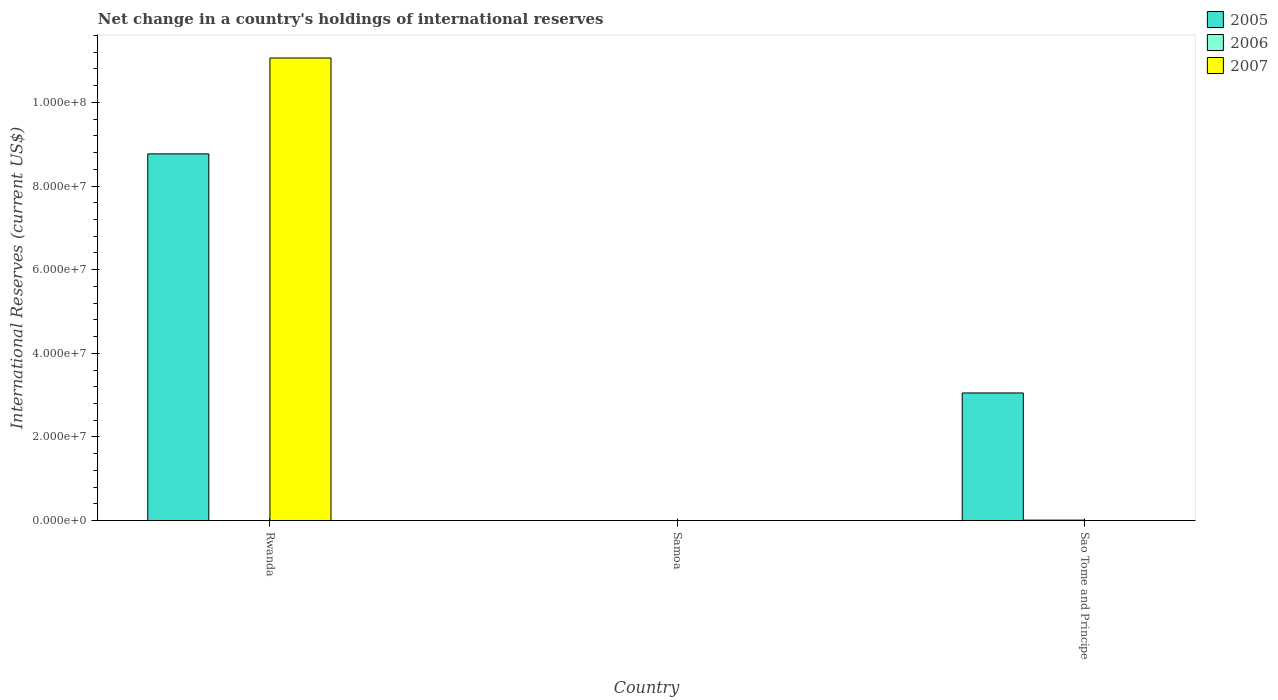How many bars are there on the 3rd tick from the right?
Ensure brevity in your answer.  2. What is the label of the 1st group of bars from the left?
Offer a terse response. Rwanda. What is the international reserves in 2005 in Samoa?
Offer a very short reply. 0. Across all countries, what is the maximum international reserves in 2006?
Make the answer very short. 1.11e+05. In which country was the international reserves in 2006 maximum?
Your response must be concise. Sao Tome and Principe. What is the total international reserves in 2006 in the graph?
Make the answer very short. 1.11e+05. What is the difference between the international reserves in 2005 in Rwanda and that in Sao Tome and Principe?
Your answer should be compact. 5.72e+07. What is the difference between the international reserves in 2005 in Sao Tome and Principe and the international reserves in 2007 in Rwanda?
Your answer should be compact. -8.01e+07. What is the average international reserves in 2005 per country?
Ensure brevity in your answer.  3.94e+07. What is the difference between the international reserves of/in 2005 and international reserves of/in 2006 in Sao Tome and Principe?
Give a very brief answer. 3.04e+07. In how many countries, is the international reserves in 2007 greater than 56000000 US$?
Your response must be concise. 1. What is the ratio of the international reserves in 2005 in Rwanda to that in Sao Tome and Principe?
Offer a very short reply. 2.87. Is the international reserves in 2005 in Rwanda less than that in Sao Tome and Principe?
Give a very brief answer. No. What is the difference between the highest and the lowest international reserves in 2005?
Offer a terse response. 8.77e+07. Is it the case that in every country, the sum of the international reserves in 2007 and international reserves in 2005 is greater than the international reserves in 2006?
Your answer should be very brief. No. How many bars are there?
Give a very brief answer. 4. Are all the bars in the graph horizontal?
Provide a succinct answer. No. How many countries are there in the graph?
Your response must be concise. 3. Does the graph contain grids?
Offer a terse response. No. Where does the legend appear in the graph?
Ensure brevity in your answer.  Top right. How many legend labels are there?
Ensure brevity in your answer.  3. How are the legend labels stacked?
Make the answer very short. Vertical. What is the title of the graph?
Your answer should be very brief. Net change in a country's holdings of international reserves. What is the label or title of the Y-axis?
Offer a terse response. International Reserves (current US$). What is the International Reserves (current US$) of 2005 in Rwanda?
Your answer should be very brief. 8.77e+07. What is the International Reserves (current US$) of 2006 in Rwanda?
Offer a terse response. 0. What is the International Reserves (current US$) in 2007 in Rwanda?
Give a very brief answer. 1.11e+08. What is the International Reserves (current US$) of 2005 in Samoa?
Make the answer very short. 0. What is the International Reserves (current US$) of 2006 in Samoa?
Give a very brief answer. 0. What is the International Reserves (current US$) in 2007 in Samoa?
Keep it short and to the point. 0. What is the International Reserves (current US$) in 2005 in Sao Tome and Principe?
Give a very brief answer. 3.05e+07. What is the International Reserves (current US$) in 2006 in Sao Tome and Principe?
Keep it short and to the point. 1.11e+05. What is the International Reserves (current US$) in 2007 in Sao Tome and Principe?
Provide a succinct answer. 0. Across all countries, what is the maximum International Reserves (current US$) of 2005?
Provide a short and direct response. 8.77e+07. Across all countries, what is the maximum International Reserves (current US$) in 2006?
Make the answer very short. 1.11e+05. Across all countries, what is the maximum International Reserves (current US$) of 2007?
Your answer should be compact. 1.11e+08. What is the total International Reserves (current US$) in 2005 in the graph?
Provide a short and direct response. 1.18e+08. What is the total International Reserves (current US$) of 2006 in the graph?
Offer a very short reply. 1.11e+05. What is the total International Reserves (current US$) in 2007 in the graph?
Offer a terse response. 1.11e+08. What is the difference between the International Reserves (current US$) of 2005 in Rwanda and that in Sao Tome and Principe?
Provide a short and direct response. 5.72e+07. What is the difference between the International Reserves (current US$) in 2005 in Rwanda and the International Reserves (current US$) in 2006 in Sao Tome and Principe?
Offer a very short reply. 8.76e+07. What is the average International Reserves (current US$) of 2005 per country?
Offer a very short reply. 3.94e+07. What is the average International Reserves (current US$) in 2006 per country?
Ensure brevity in your answer.  3.70e+04. What is the average International Reserves (current US$) of 2007 per country?
Offer a terse response. 3.69e+07. What is the difference between the International Reserves (current US$) of 2005 and International Reserves (current US$) of 2007 in Rwanda?
Your answer should be very brief. -2.29e+07. What is the difference between the International Reserves (current US$) of 2005 and International Reserves (current US$) of 2006 in Sao Tome and Principe?
Your answer should be compact. 3.04e+07. What is the ratio of the International Reserves (current US$) of 2005 in Rwanda to that in Sao Tome and Principe?
Keep it short and to the point. 2.87. What is the difference between the highest and the lowest International Reserves (current US$) in 2005?
Provide a short and direct response. 8.77e+07. What is the difference between the highest and the lowest International Reserves (current US$) of 2006?
Ensure brevity in your answer.  1.11e+05. What is the difference between the highest and the lowest International Reserves (current US$) of 2007?
Your answer should be very brief. 1.11e+08. 